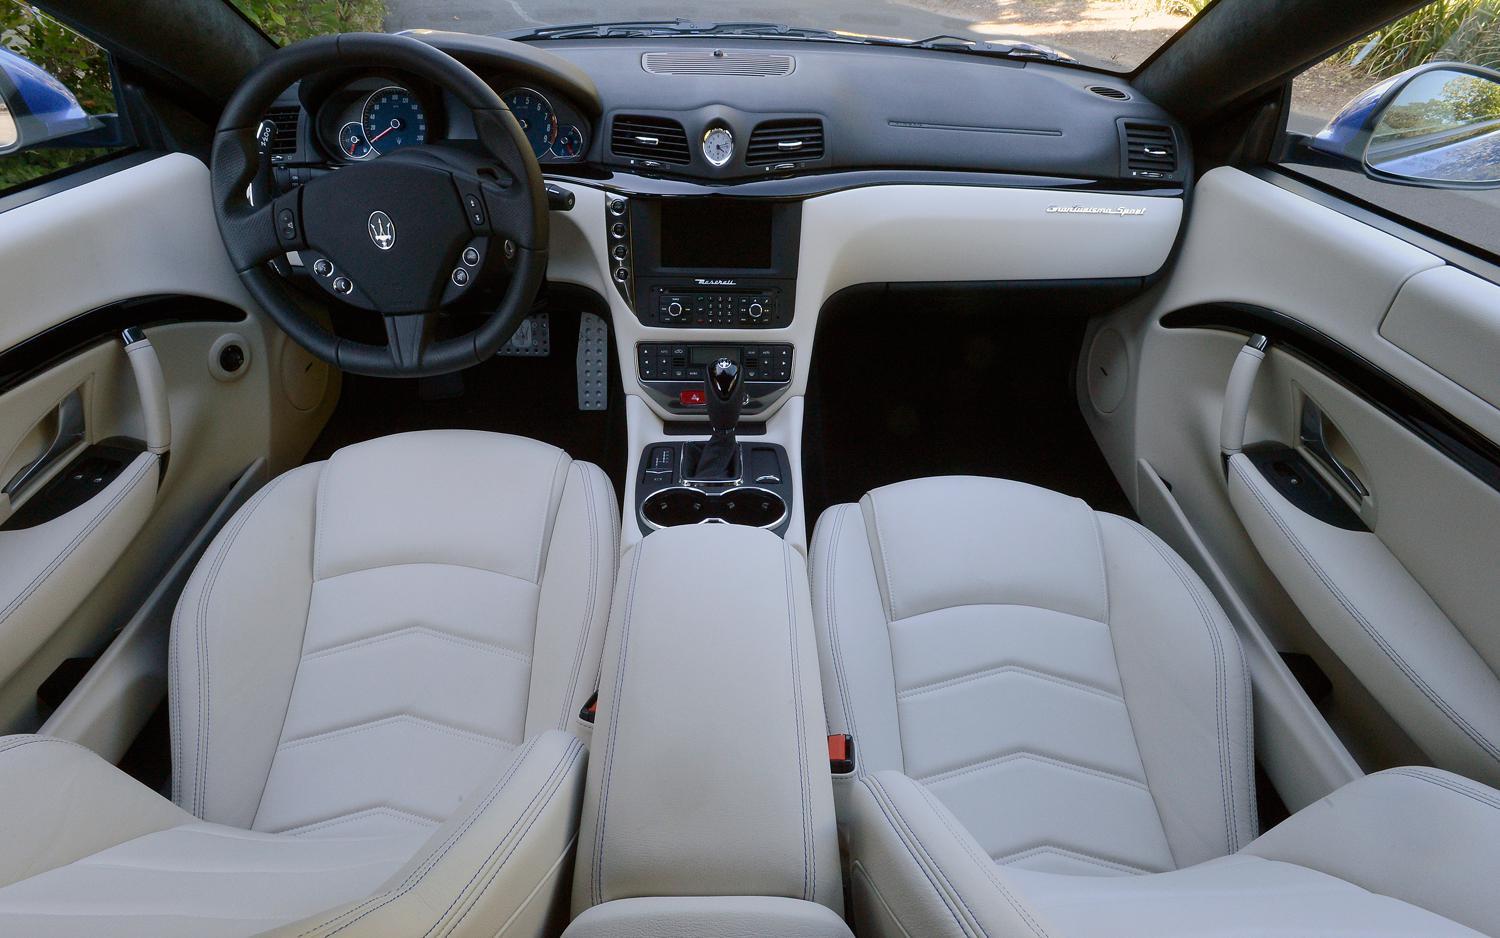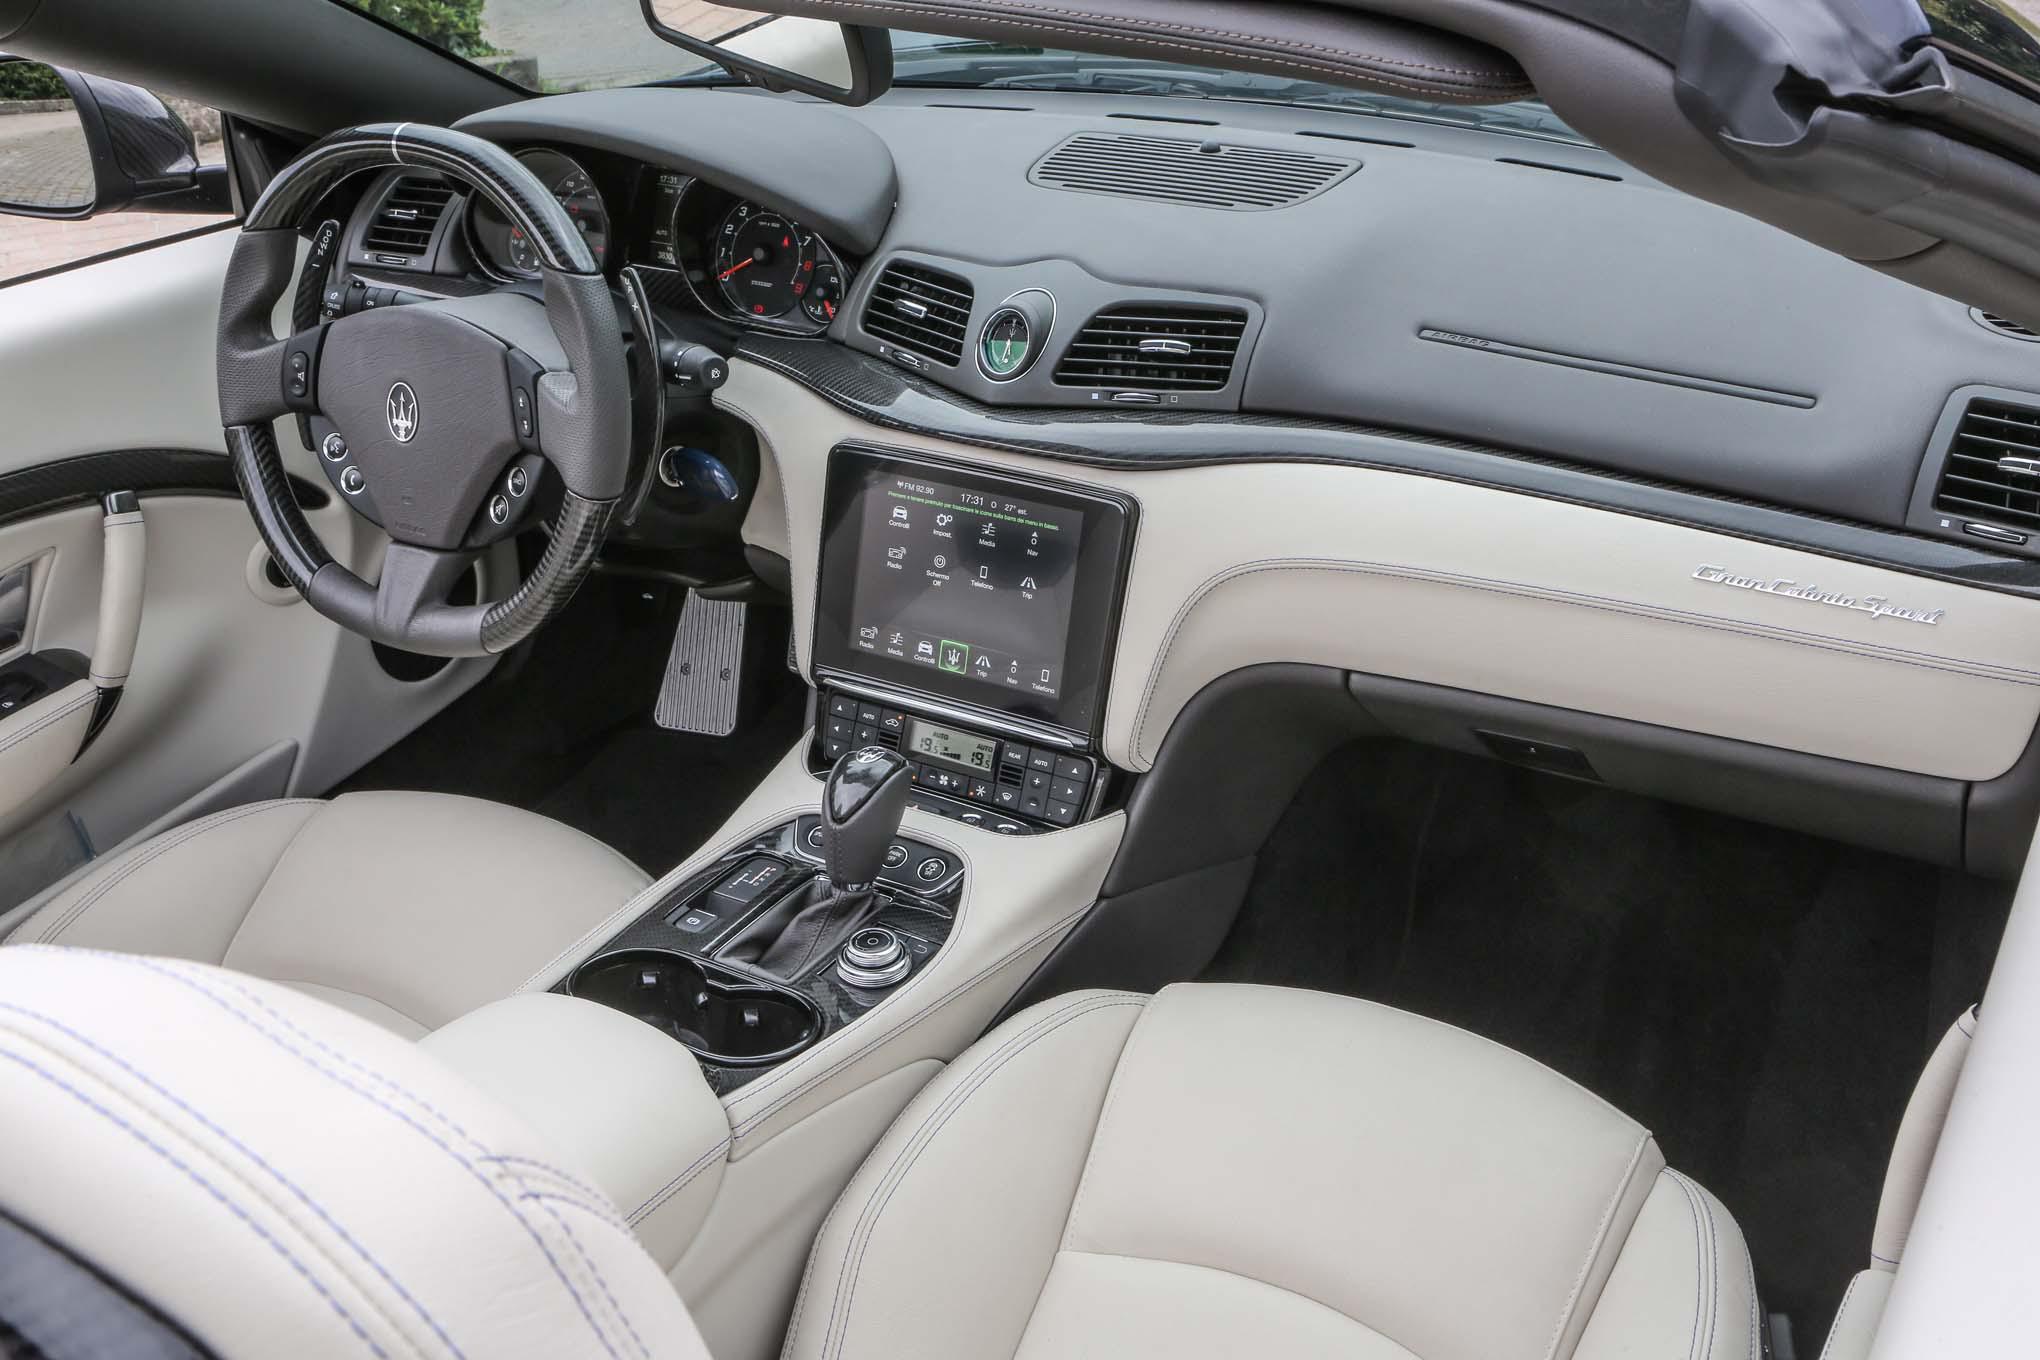The first image is the image on the left, the second image is the image on the right. For the images displayed, is the sentence "Both car interiors show white upholstery, and no other color upholstery on the seats." factually correct? Answer yes or no. Yes. The first image is the image on the left, the second image is the image on the right. Considering the images on both sides, is "The steering wheel is visible on both cars, but the back seat is not." valid? Answer yes or no. Yes. 